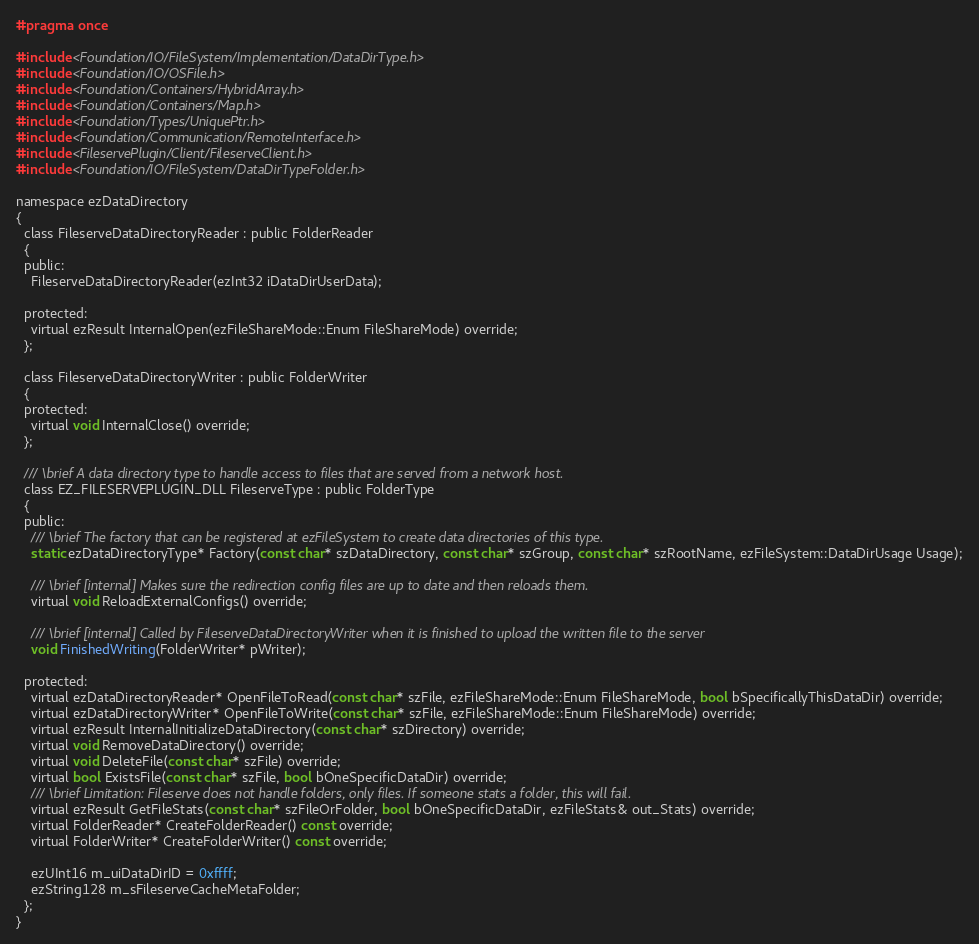Convert code to text. <code><loc_0><loc_0><loc_500><loc_500><_C_>#pragma once

#include <Foundation/IO/FileSystem/Implementation/DataDirType.h>
#include <Foundation/IO/OSFile.h>
#include <Foundation/Containers/HybridArray.h>
#include <Foundation/Containers/Map.h>
#include <Foundation/Types/UniquePtr.h>
#include <Foundation/Communication/RemoteInterface.h>
#include <FileservePlugin/Client/FileserveClient.h>
#include <Foundation/IO/FileSystem/DataDirTypeFolder.h>

namespace ezDataDirectory
{
  class FileserveDataDirectoryReader : public FolderReader
  {
  public:
    FileserveDataDirectoryReader(ezInt32 iDataDirUserData);

  protected:
    virtual ezResult InternalOpen(ezFileShareMode::Enum FileShareMode) override;
  };

  class FileserveDataDirectoryWriter : public FolderWriter
  {
  protected:
    virtual void InternalClose() override;
  };

  /// \brief A data directory type to handle access to files that are served from a network host.
  class EZ_FILESERVEPLUGIN_DLL FileserveType : public FolderType
  {
  public:
    /// \brief The factory that can be registered at ezFileSystem to create data directories of this type.
    static ezDataDirectoryType* Factory(const char* szDataDirectory, const char* szGroup, const char* szRootName, ezFileSystem::DataDirUsage Usage);

    /// \brief [internal] Makes sure the redirection config files are up to date and then reloads them.
    virtual void ReloadExternalConfigs() override;

    /// \brief [internal] Called by FileserveDataDirectoryWriter when it is finished to upload the written file to the server
    void FinishedWriting(FolderWriter* pWriter);

  protected:
    virtual ezDataDirectoryReader* OpenFileToRead(const char* szFile, ezFileShareMode::Enum FileShareMode, bool bSpecificallyThisDataDir) override;
    virtual ezDataDirectoryWriter* OpenFileToWrite(const char* szFile, ezFileShareMode::Enum FileShareMode) override;
    virtual ezResult InternalInitializeDataDirectory(const char* szDirectory) override;
    virtual void RemoveDataDirectory() override;
    virtual void DeleteFile(const char* szFile) override;
    virtual bool ExistsFile(const char* szFile, bool bOneSpecificDataDir) override;
    /// \brief Limitation: Fileserve does not handle folders, only files. If someone stats a folder, this will fail.
    virtual ezResult GetFileStats(const char* szFileOrFolder, bool bOneSpecificDataDir, ezFileStats& out_Stats) override;
    virtual FolderReader* CreateFolderReader() const override;
    virtual FolderWriter* CreateFolderWriter() const override;

    ezUInt16 m_uiDataDirID = 0xffff;
    ezString128 m_sFileserveCacheMetaFolder;
  };
}



</code> 